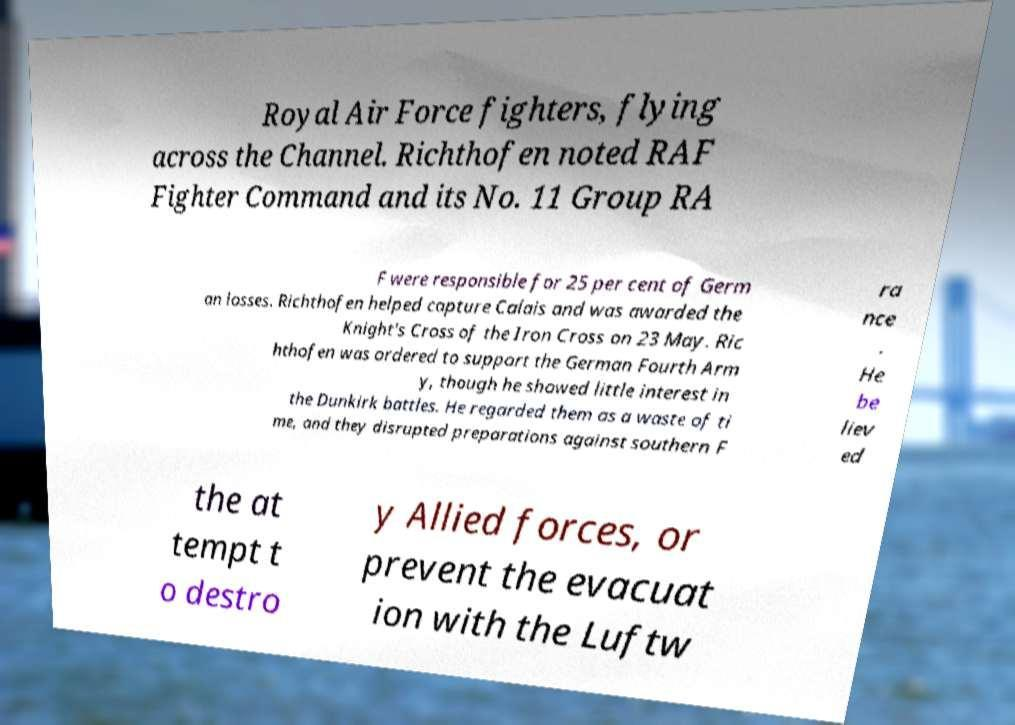For documentation purposes, I need the text within this image transcribed. Could you provide that? Royal Air Force fighters, flying across the Channel. Richthofen noted RAF Fighter Command and its No. 11 Group RA F were responsible for 25 per cent of Germ an losses. Richthofen helped capture Calais and was awarded the Knight's Cross of the Iron Cross on 23 May. Ric hthofen was ordered to support the German Fourth Arm y, though he showed little interest in the Dunkirk battles. He regarded them as a waste of ti me, and they disrupted preparations against southern F ra nce . He be liev ed the at tempt t o destro y Allied forces, or prevent the evacuat ion with the Luftw 